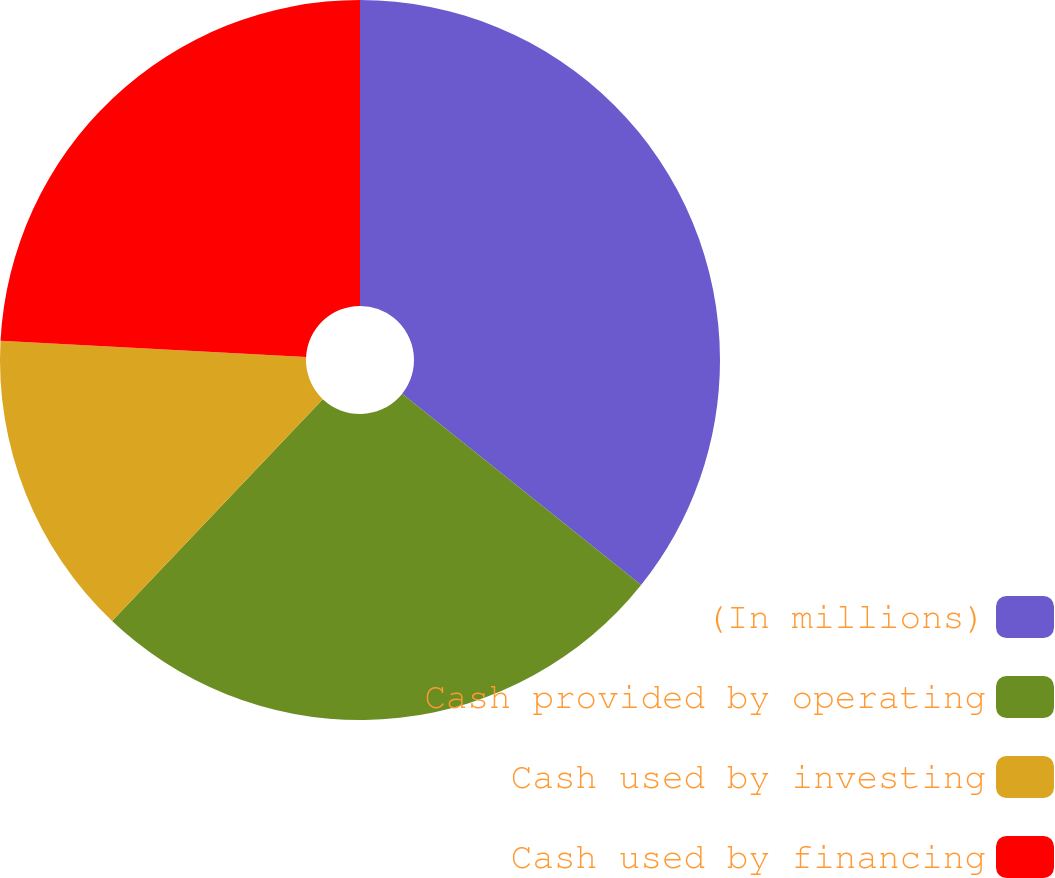<chart> <loc_0><loc_0><loc_500><loc_500><pie_chart><fcel>(In millions)<fcel>Cash provided by operating<fcel>Cash used by investing<fcel>Cash used by financing<nl><fcel>35.74%<fcel>26.35%<fcel>13.76%<fcel>24.15%<nl></chart> 